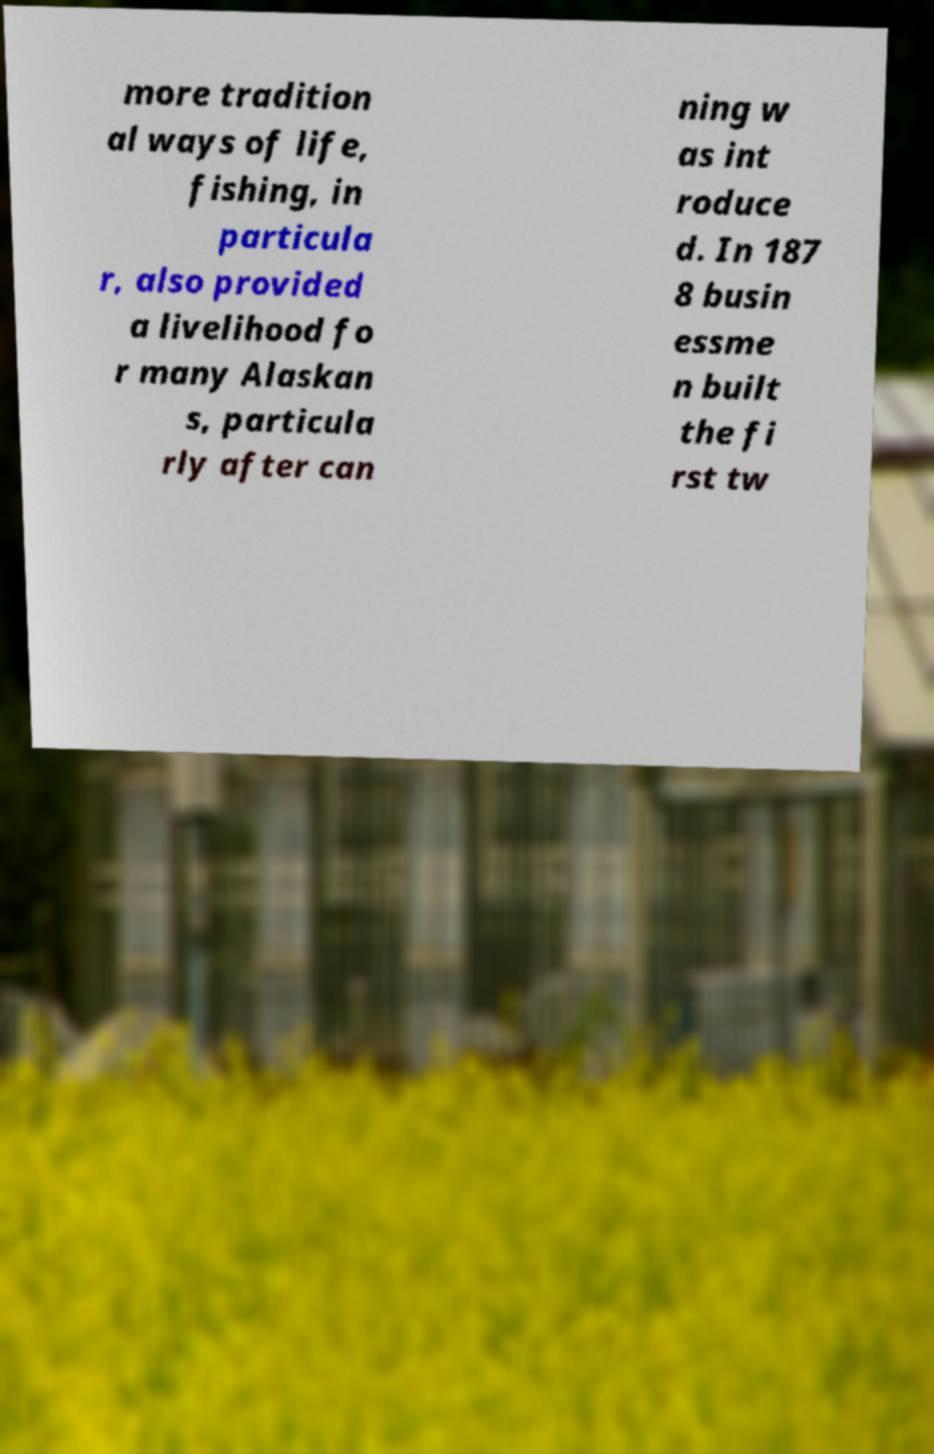What messages or text are displayed in this image? I need them in a readable, typed format. more tradition al ways of life, fishing, in particula r, also provided a livelihood fo r many Alaskan s, particula rly after can ning w as int roduce d. In 187 8 busin essme n built the fi rst tw 